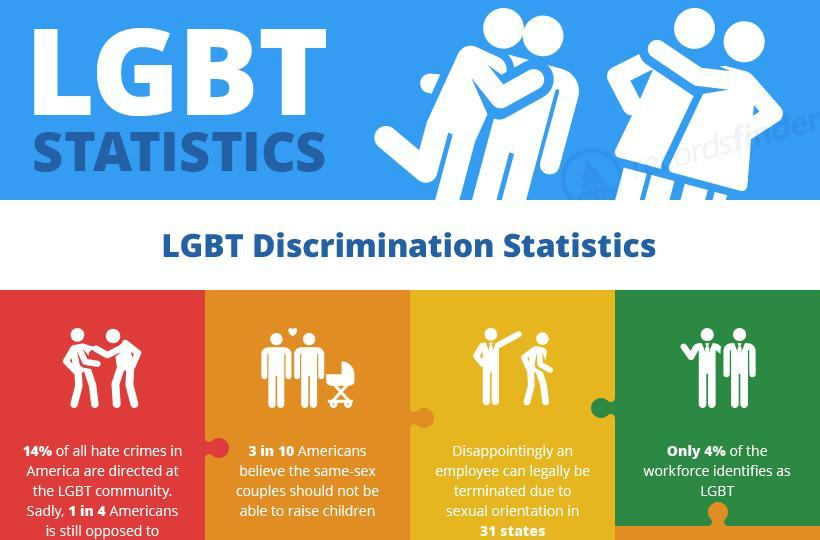what percentage of americans believe that same-sex couples should not be able to raise children
Answer the question with a short phrase. 30 what is the LGBT workforce 4% 